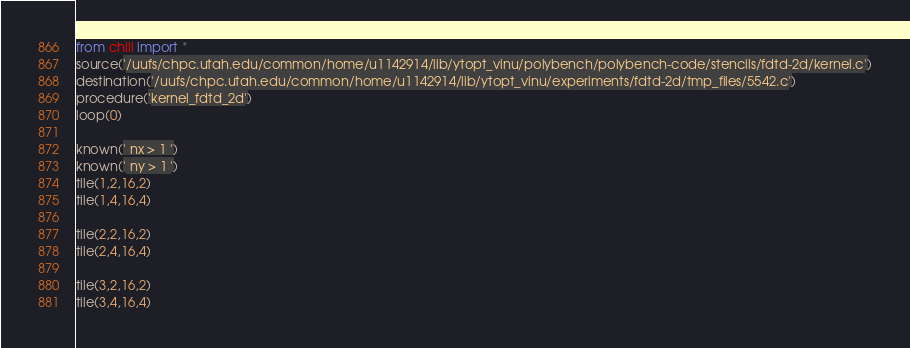<code> <loc_0><loc_0><loc_500><loc_500><_Python_>from chill import *
source('/uufs/chpc.utah.edu/common/home/u1142914/lib/ytopt_vinu/polybench/polybench-code/stencils/fdtd-2d/kernel.c')
destination('/uufs/chpc.utah.edu/common/home/u1142914/lib/ytopt_vinu/experiments/fdtd-2d/tmp_files/5542.c')
procedure('kernel_fdtd_2d')
loop(0)

known(' nx > 1 ')
known(' ny > 1 ')
tile(1,2,16,2)
tile(1,4,16,4)

tile(2,2,16,2)
tile(2,4,16,4)

tile(3,2,16,2)
tile(3,4,16,4)

</code> 